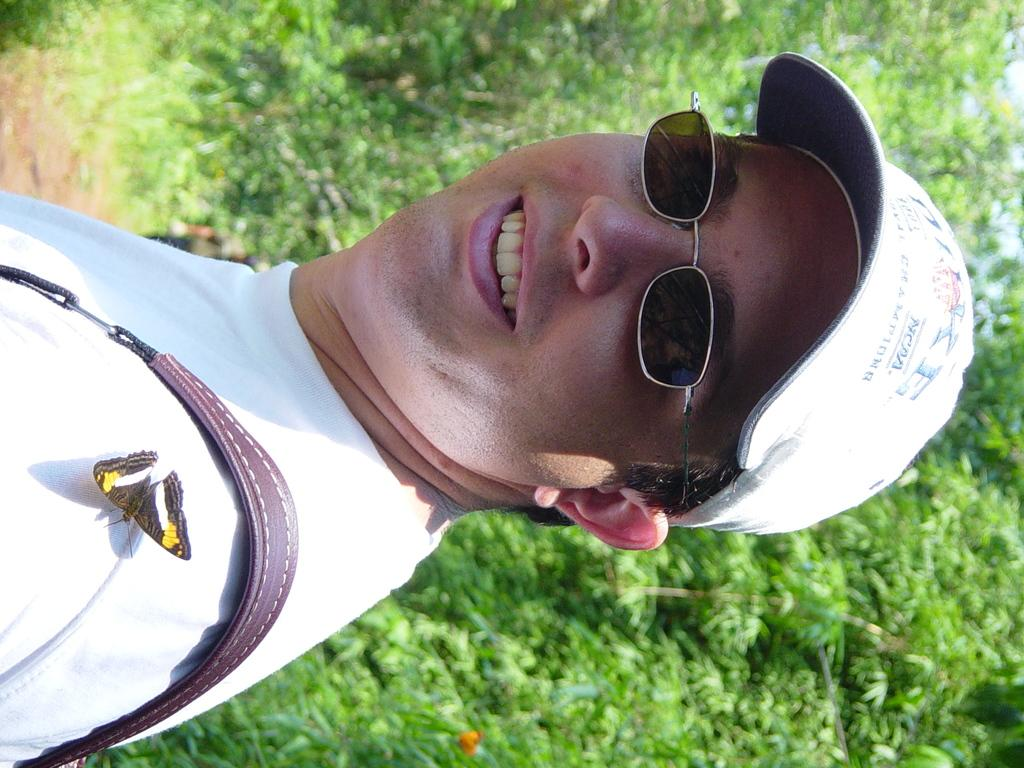Who is the main subject in the image? There is a person in the center of the image. What accessories is the person wearing? The person is wearing spectacles and a cap. What can be seen in the background of the image? There are trees, plants, and the sky visible in the background of the image. What type of hate can be seen emanating from the person in the image? There is no indication of hate or any negative emotion in the image; the person is simply standing and wearing spectacles and a cap. 